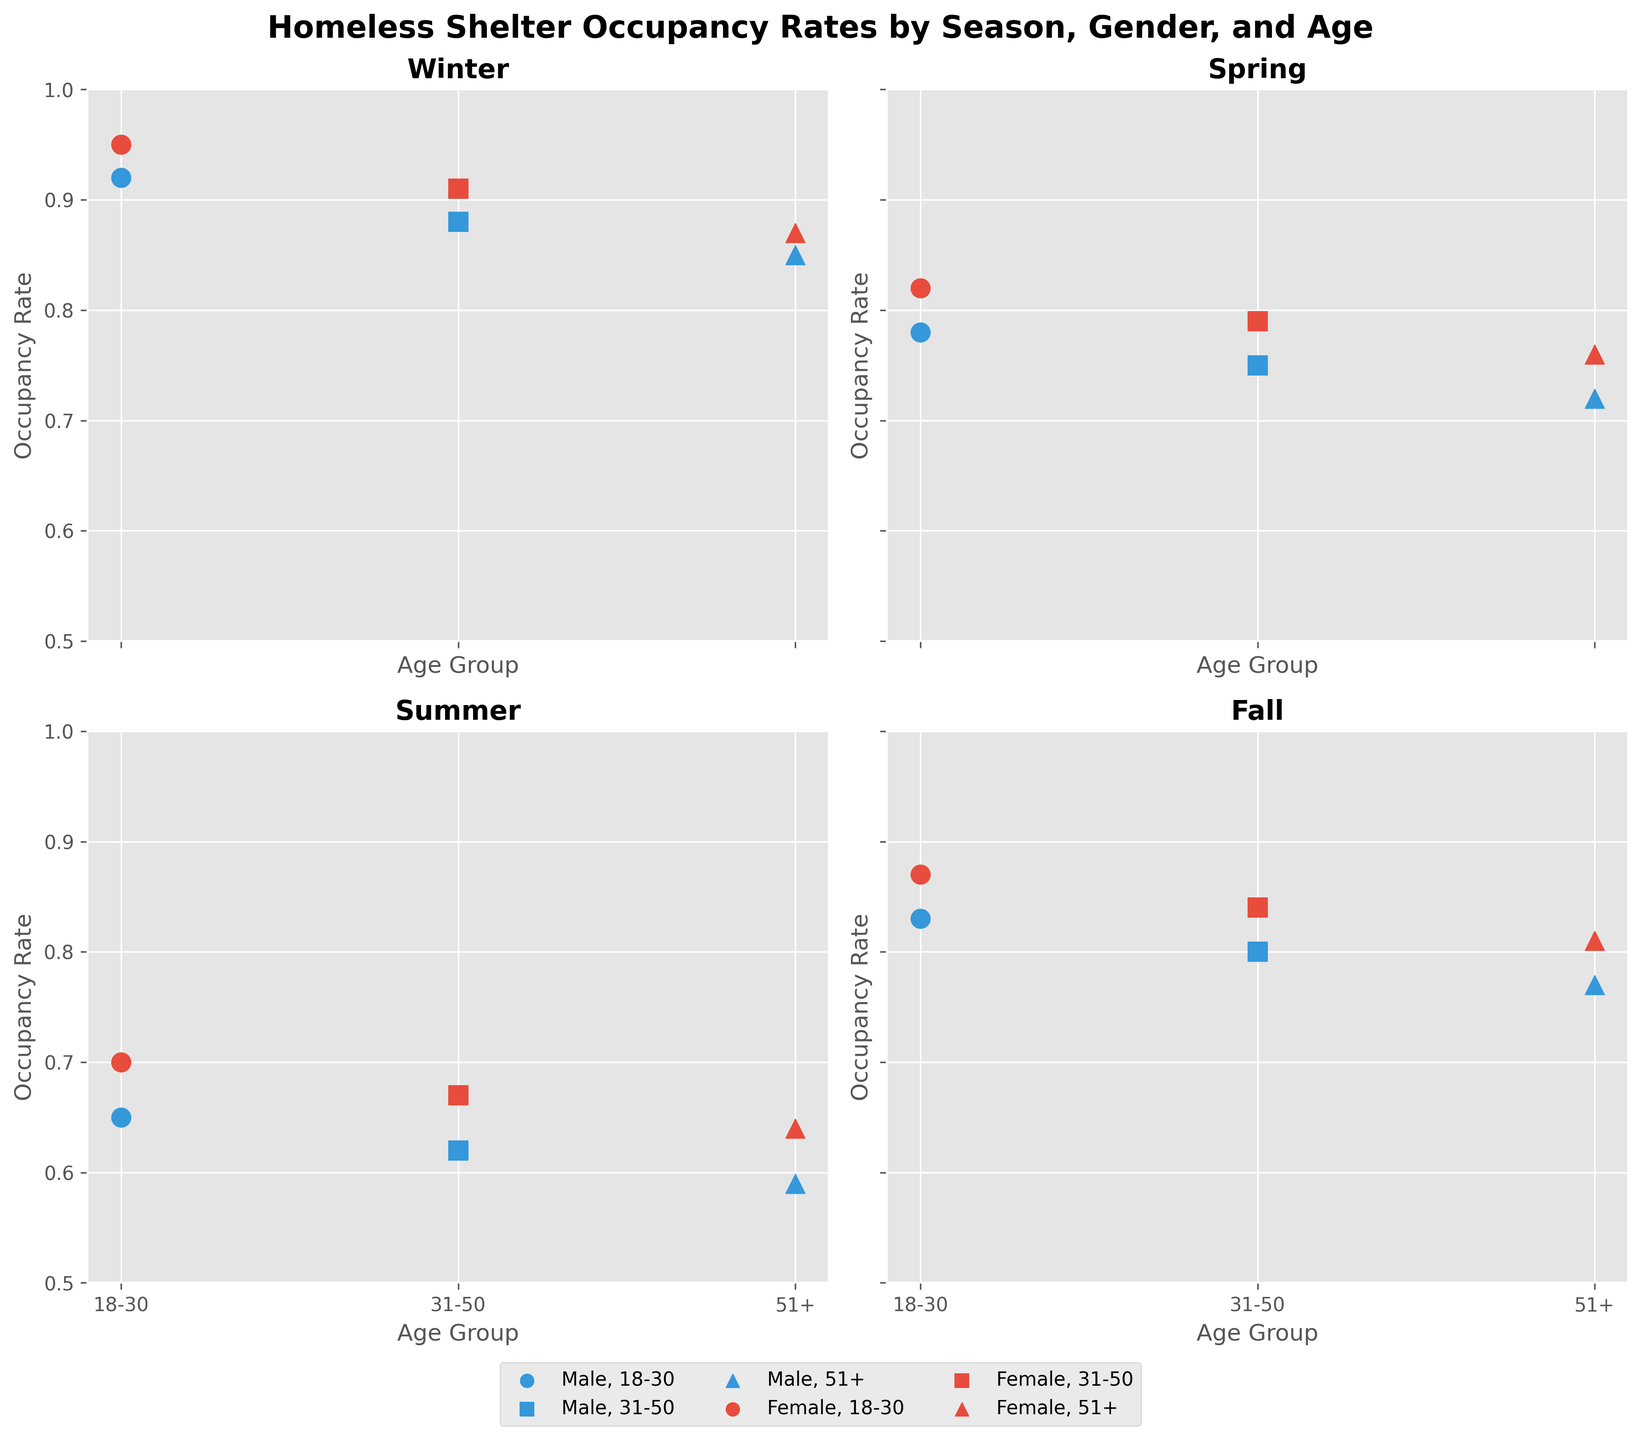What's the title of the figure? The title of the figure is displayed prominently at the top and reads "Homeless Shelter Occupancy Rates by Season, Gender, and Age".
Answer: Homeless Shelter Occupancy Rates by Season, Gender, and Age How many seasons are represented in the figure? The figure consists of four subplots, each titled with a different season: Winter, Spring, Summer, and Fall.
Answer: 4 What marker shapes are used for different age groups? In the figure, circles represent the age group 18-30, squares represent 31-50, and triangles represent 51+.
Answer: Circles, squares, triangles Which gender has the highest occupancy rate in winter for the age group 18-30? Looking at the subplot for Winter, the red circles (indicating Female, 18-30) show a higher position on the y-axis than the blue circles (indicating Male, 18-30). The highest point at 0.95 is for the Female, 18-30 group.
Answer: Female What is the difference in occupancy rate between male and female in summer for the age group 31-50? In the subplot for Summer, the blue squares (Male, 31-50) are at 0.62, while the red squares (Female, 31-50) are at 0.67. The difference is 0.67 - 0.62 = 0.05.
Answer: 0.05 Which season has the lowest occupancy rate overall? By examining the subplots for each season, Summer consistently shows the lowest occupancy rates for all groups compared to the other seasons. The lowest values (all below 0.65) are observed in Summer.
Answer: Summer How does the occupancy rate for males aged 51+ in Fall compare to Winter? The subplot for Fall shows the male 51+ group (blue triangles) at an occupancy rate of 0.77. For Winter, the same group is at 0.85. Therefore, the occupancy rate is higher in Winter by 0.85 - 0.77 = 0.08.
Answer: Higher in Winter by 0.08 What trends can be observed in terms of occupancy rates across seasons for females aged 18-30? Observing the subplots, for females aged 18-30 (red circles), the occupancy rates are highest in Winter (0.95), followed by Fall (0.87), Spring (0.82), and are lowest in Summer (0.70). There is a noticeable drop from Winter to Summer.
Answer: Drop from Winter to Summer How consistent are the occupancy rates within each gender across different age groups in Spring? In the Spring subplot, males have occupancy rates of 0.78, 0.75, and 0.72 for 18-30, 31-50, and 51+ respectively, which shows a slight decline with age. Similarly, females have rates of 0.82, 0.79, and 0.76 for the same age groups, also showing a slight decline. Both genders exhibit relatively consistent and smooth declines within their groups.
Answer: Slight decline with age for both genders What can we infer about the occupancy rates for the oldest age group (51+) during the year? In the subplots for each season, the 51+ age group (triangles) shows varying rates: 0.85 (Winter), 0.76 (Spring), 0.64 (Summer), and 0.81 (Fall). The occupancy rate is highest in Winter, dips in Spring, reaches its lowest in Summer, and rises again in Fall, indicating a seasonal fluctuation for the oldest group.
Answer: Seasonal fluctuation with highest in Winter and lowest in Summer 